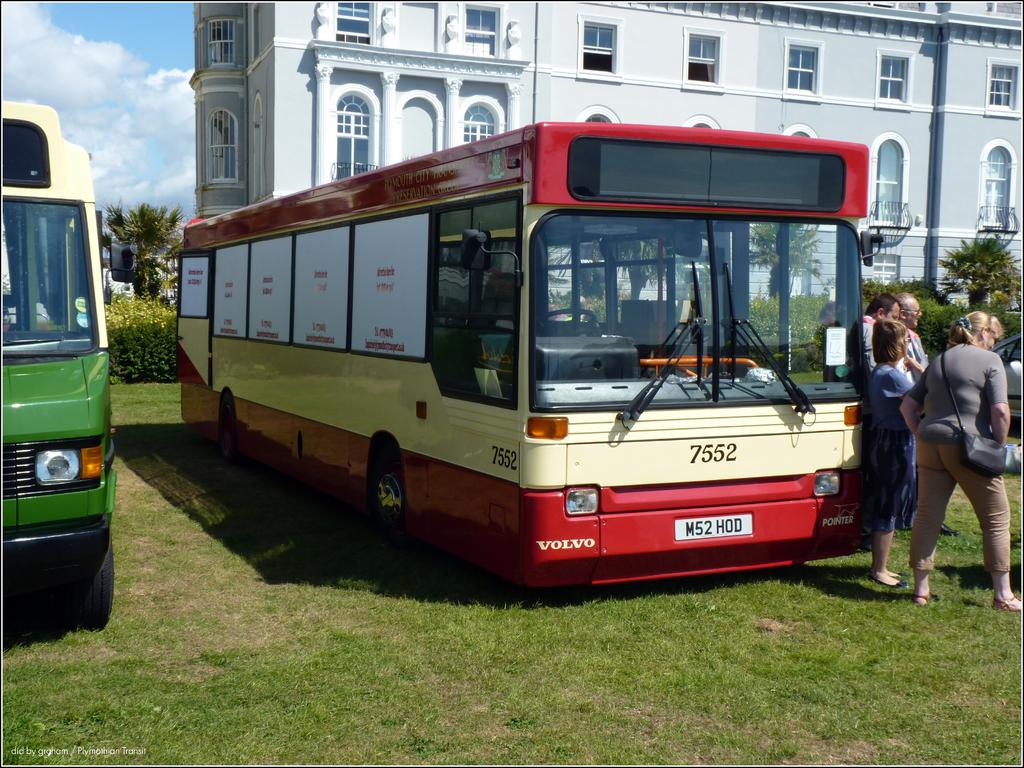What type of vehicles can be seen in the image? There are buses and a car in the image. What are the people in the image doing? There is a group of people standing on the ground. What type of vegetation is present in the image? Trees and grass are visible in the image. What type of structure can be seen in the image? There is a building with windows in the image. What object can be seen in the hands of one of the people? There is a bag in the image. What can be seen in the background of the image? The sky with clouds is visible in the background of the image. How do the trees in the image show respect to the building? Trees do not show respect; they are inanimate objects. The image simply shows trees and a building in the same scene. 